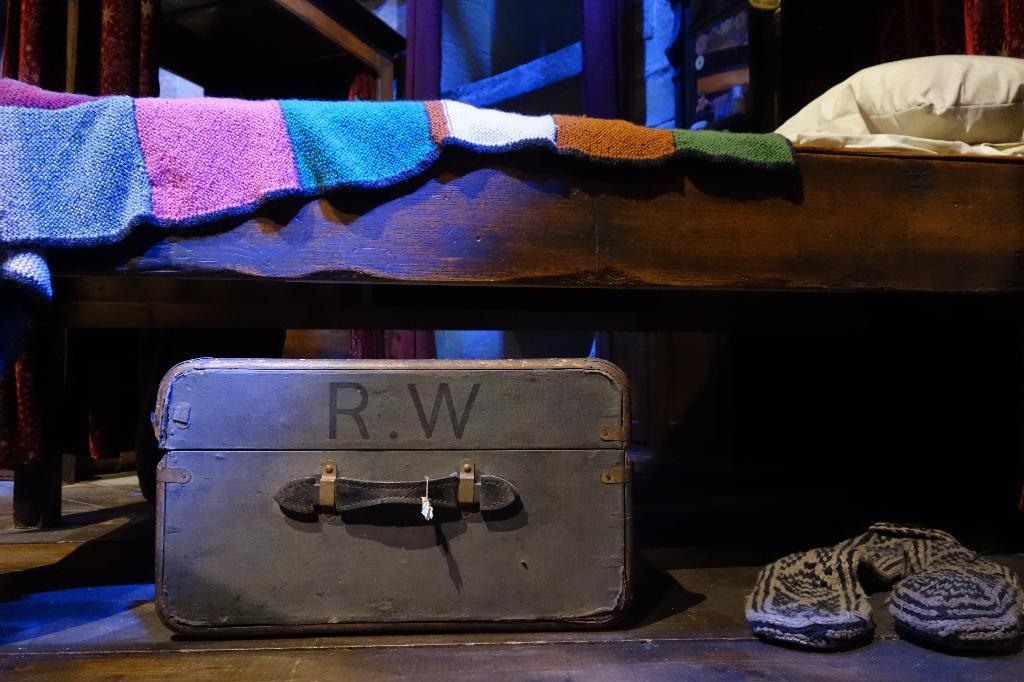What type of space is depicted in the image? There is a room in the image. What piece of furniture is present in the room? There is a cot in the room. What is placed on top of the cot? There is a cloth and a pillow on the cot. What is located at the bottom of the cot? There is a box and socks at the bottom of the cot. What type of truck can be seen parked outside the room in the image? There is no truck visible in the image; it only shows a room with a cot and other items. 